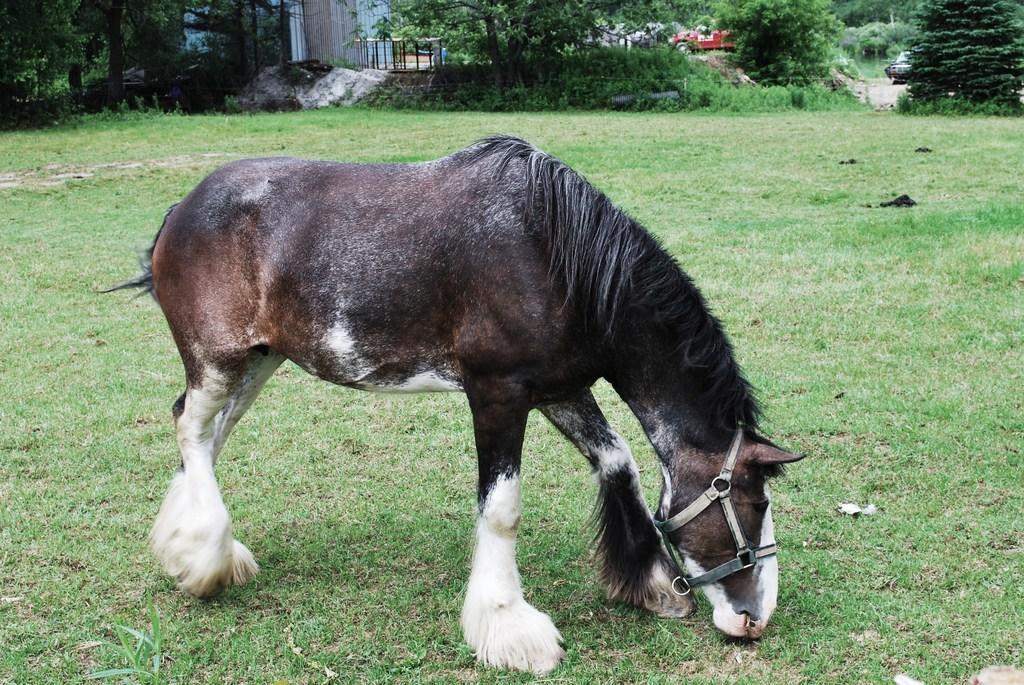Describe this image in one or two sentences. In this picture we can see a horse standing, at the bottom there is grass, we can see trees in the background, we can see a vehicle here. 